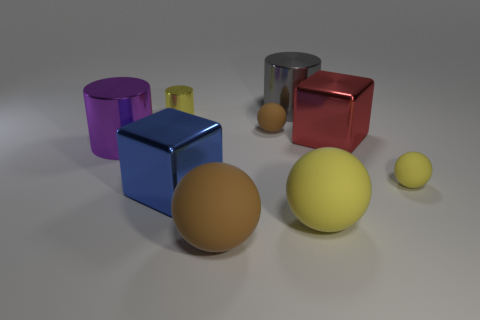Subtract all red spheres. Subtract all yellow blocks. How many spheres are left? 4 Add 1 big gray matte cylinders. How many objects exist? 10 Subtract all cylinders. How many objects are left? 6 Add 2 tiny brown balls. How many tiny brown balls exist? 3 Subtract 0 green cubes. How many objects are left? 9 Subtract all metallic cylinders. Subtract all gray metal cylinders. How many objects are left? 5 Add 4 big purple cylinders. How many big purple cylinders are left? 5 